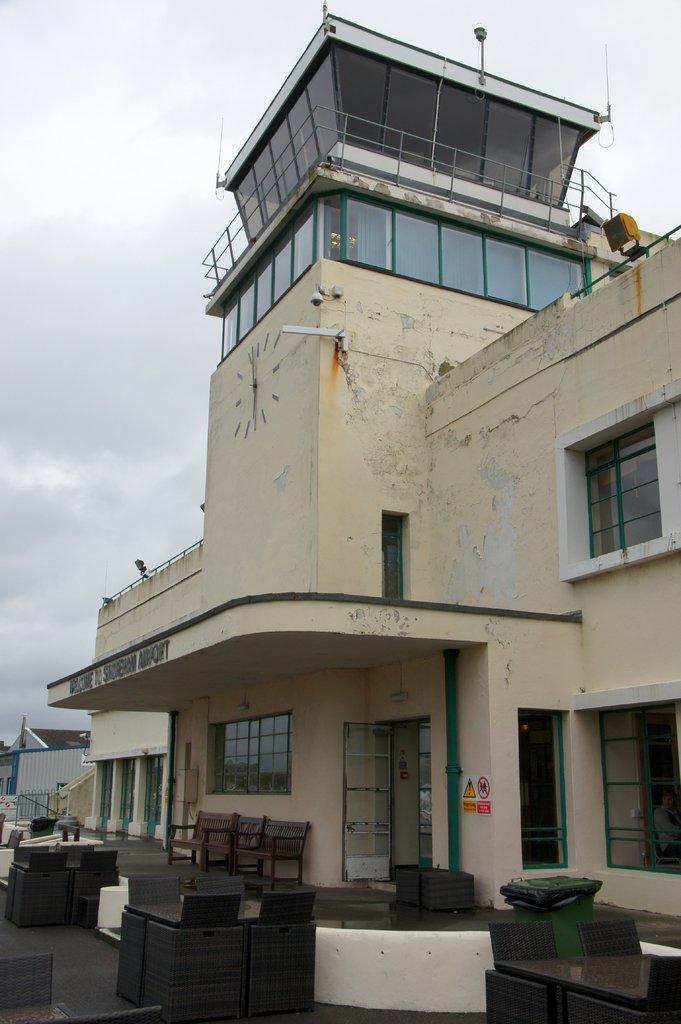How would you summarize this image in a sentence or two? In this picture we can see a building. On the bottom can see tables, chairs, couch and other objects. At the top we can see sky and clouds. In the background we can see tree and shed. 